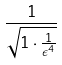Convert formula to latex. <formula><loc_0><loc_0><loc_500><loc_500>\frac { 1 } { \sqrt { 1 \cdot \frac { 1 } { \epsilon ^ { 4 } } } }</formula> 